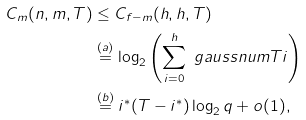Convert formula to latex. <formula><loc_0><loc_0><loc_500><loc_500>C _ { m } ( n , m , T ) & \leq C _ { f - m } ( h , h , T ) \\ & \stackrel { ( a ) } { = } \log _ { 2 } \left ( \sum _ { i = 0 } ^ { h } \ g a u s s n u m { T } { i } \right ) \\ & \stackrel { ( b ) } { = } i ^ { * } ( T - i ^ { * } ) \log _ { 2 } { q } + o ( 1 ) ,</formula> 